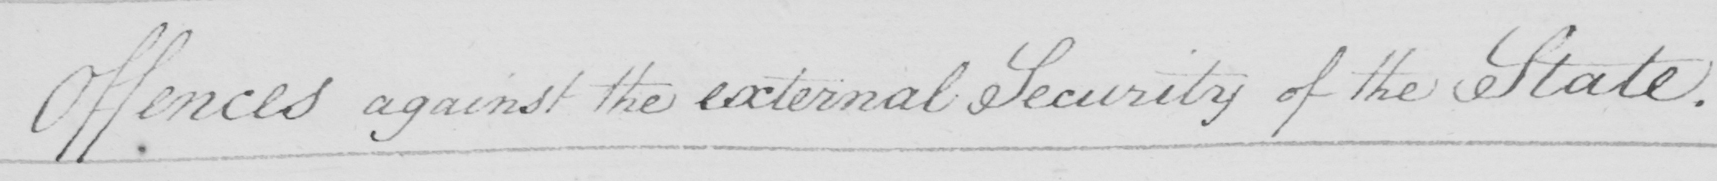What text is written in this handwritten line? Offences against the external Security of the State . 